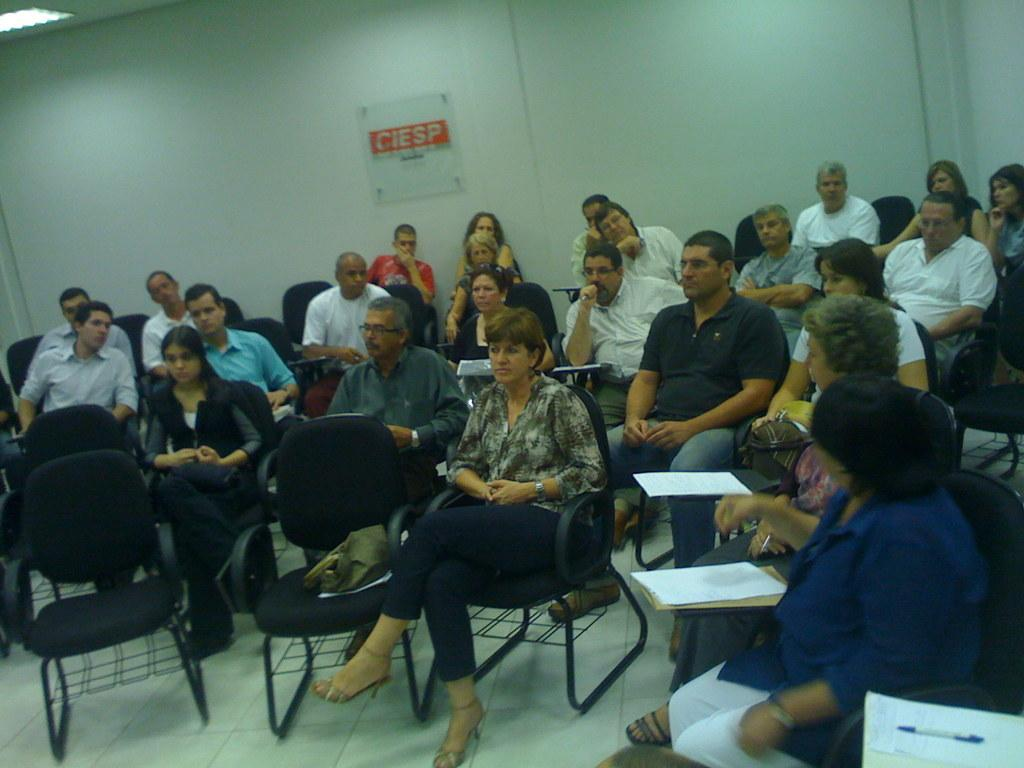What is the main subject of the image? The main subject of the image is a group of people. Where are the people located in the image? The people are sitting in a room. What are the people sitting on? The people are sitting on chairs. Can you describe the clothing of the leftmost woman? The leftmost woman is wearing a blue shirt and a white pant. What is visible on the wall behind the people? The note "CIESP" is written on the wall. What religion is being practiced by the group of people in the image? There is no indication of any religious practice in the image; it simply shows a group of people sitting in a room. 